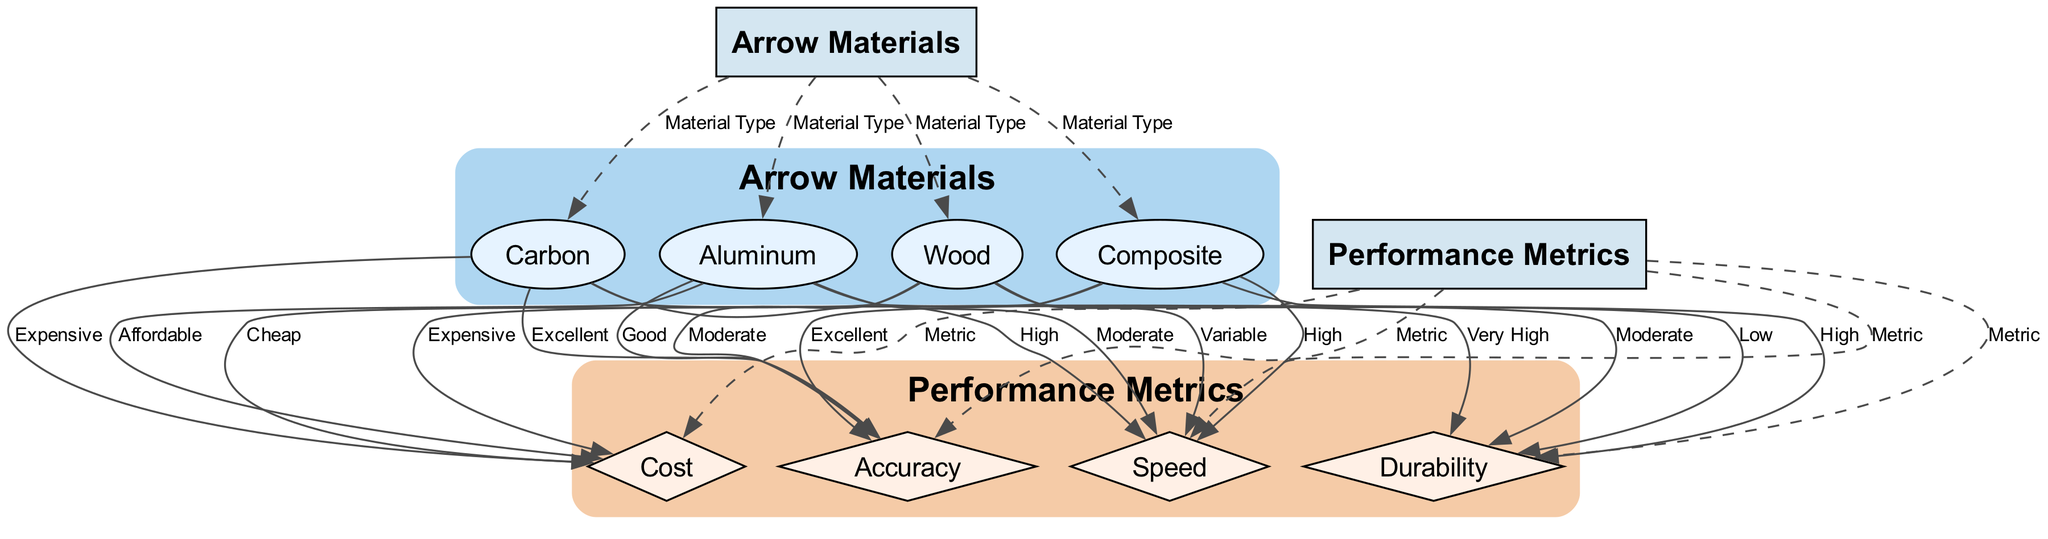What are the four types of arrow materials displayed? The diagram lists four arrow materials: Carbon, Aluminum, Wood, and Composite. This can be identified by reviewing the "Arrow Materials" node and observing the connections directly leading to these material types.
Answer: Carbon, Aluminum, Wood, Composite Which arrow material has the highest durability? By analyzing the connections from each material to the "Durability" metric, we see that Carbon has a connection labeled "Very High," indicating the highest durability among the materials.
Answer: Carbon How many performance metrics are represented in the diagram? The diagram shows four performance metrics: Speed, Durability, Cost, and Accuracy. This can be confirmed by counting the connections leading from the "Performance Metrics" node to each of these metrics.
Answer: Four Which material type is associated with a "Variable" speed? Looking at the edge from Wood to Speed, it is labeled as "Variable." This shows that among the listed materials, Wood is the one that exhibits variable speed performance characteristics.
Answer: Wood What is the cost associated with Composite arrow materials? The connection from Composite to Cost in the diagram is labeled "Expensive," indicating that the cost associated with Composite materials is high.
Answer: Expensive Which arrow material provides excellent accuracy? By checking the edges leading from each material to the "Accuracy" metric, we find that both Carbon and Composite are labeled as "Excellent," suggesting they have the best accuracy. However, the question specifies an arrow material, so we can list the first found: Carbon.
Answer: Carbon How does the speed of Aluminum compare to that of Wood? The speed of Aluminum is labeled "Moderate," whereas Wood's speed is noted as "Variable." To compare, we determine that Aluminum provides a more consistent performance in speed compared to the variability associated with Wood.
Answer: Moderate Which performance metric is defined as 'Low' for Wood? The connection from Wood to the "Durability" metric indicates "Low." This means that Wood is associated with the lowest durability performance compared to other materials, as labeled in the diagram.
Answer: Low 